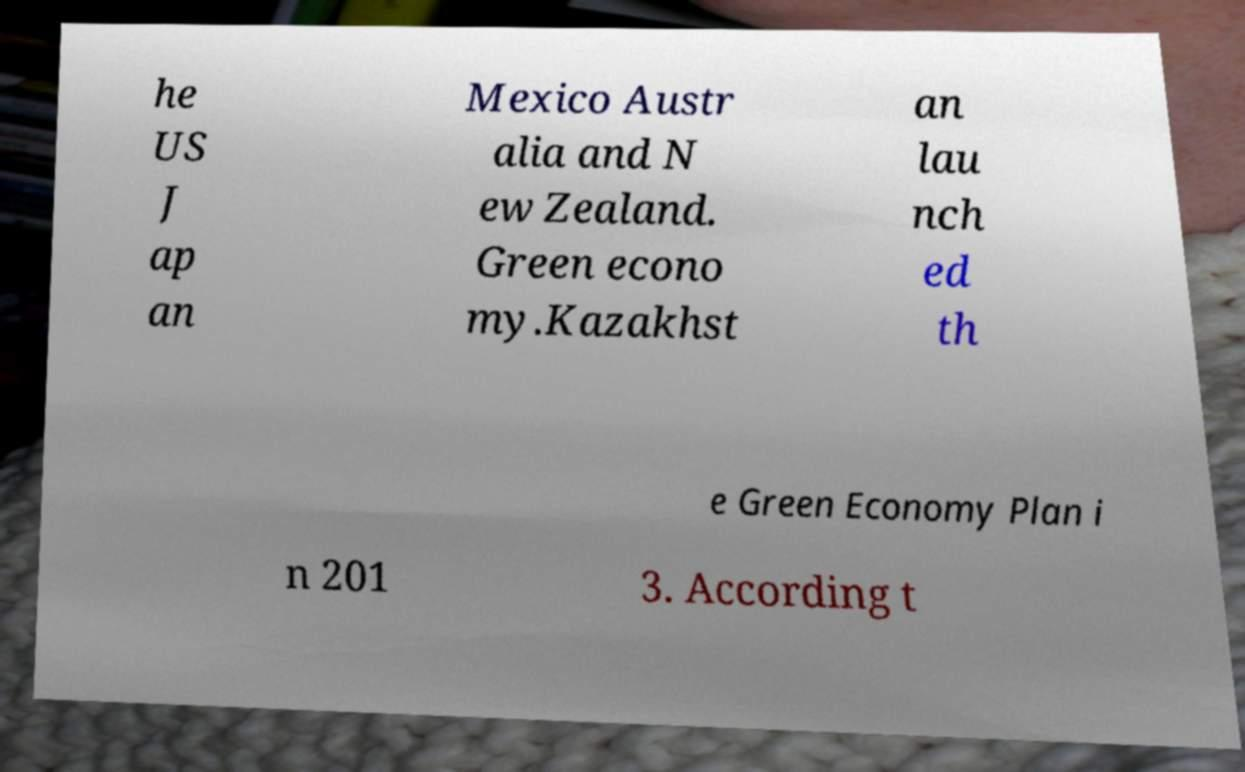I need the written content from this picture converted into text. Can you do that? he US J ap an Mexico Austr alia and N ew Zealand. Green econo my.Kazakhst an lau nch ed th e Green Economy Plan i n 201 3. According t 